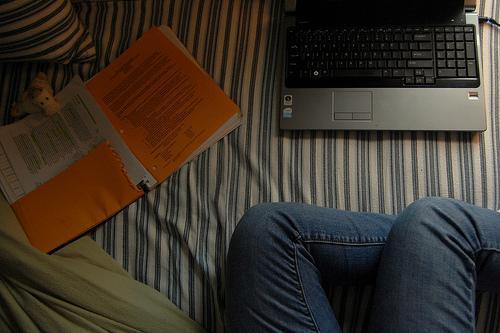How many laptops are there?
Give a very brief answer. 1. 